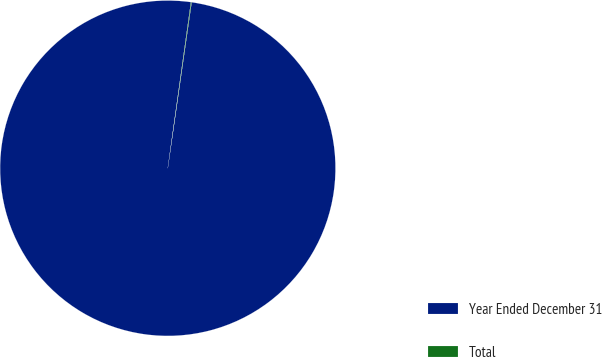<chart> <loc_0><loc_0><loc_500><loc_500><pie_chart><fcel>Year Ended December 31<fcel>Total<nl><fcel>99.94%<fcel>0.06%<nl></chart> 